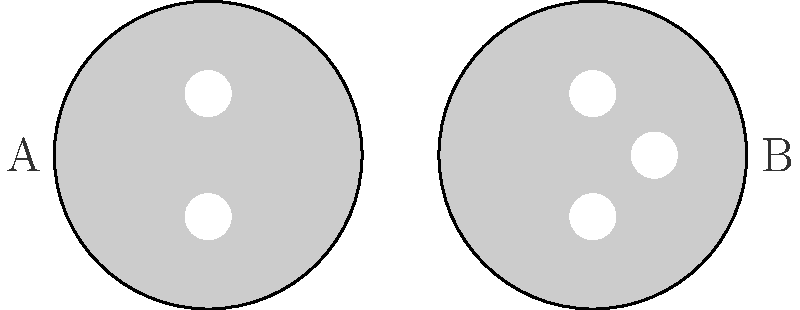As a retired nurse providing first aid support during performances, you need to be aware of potential electrical hazards. Looking at the electrical outlets shown in the image, which one is typically associated with a higher voltage rating and why might this be important in a performance setting? To answer this question, let's analyze the two outlet types shown in the image:

1. Outlet A: This is a two-prong outlet, typically found in older buildings or used for lower voltage applications.
   - Usually rated for 110-120V in North America
   - Less common in modern performance venues

2. Outlet B: This is a three-prong outlet, which is the standard in most modern buildings.
   - Typically rated for 220-240V in many countries
   - The third prong provides a ground connection for safety

3. Importance in a performance setting:
   - Higher voltage (Outlet B) can power more demanding equipment often used in performances
   - The grounded outlet (B) offers better protection against electrical faults
   - Understanding the voltage helps in assessing potential risks and appropriate first aid measures

4. Safety considerations:
   - Higher voltage outlets pose a greater risk of severe electric shock
   - Proper grounding (in Outlet B) can prevent some types of electrical accidents
   - Awareness of outlet types helps in quickly identifying potential hazards in various performance venues

Therefore, Outlet B (three-prong) is typically associated with a higher voltage rating. This knowledge is crucial for a first aid provider to assess potential risks and respond appropriately to any electrical accidents that may occur during a performance.
Answer: Outlet B (three-prong), typically rated for 220-240V 